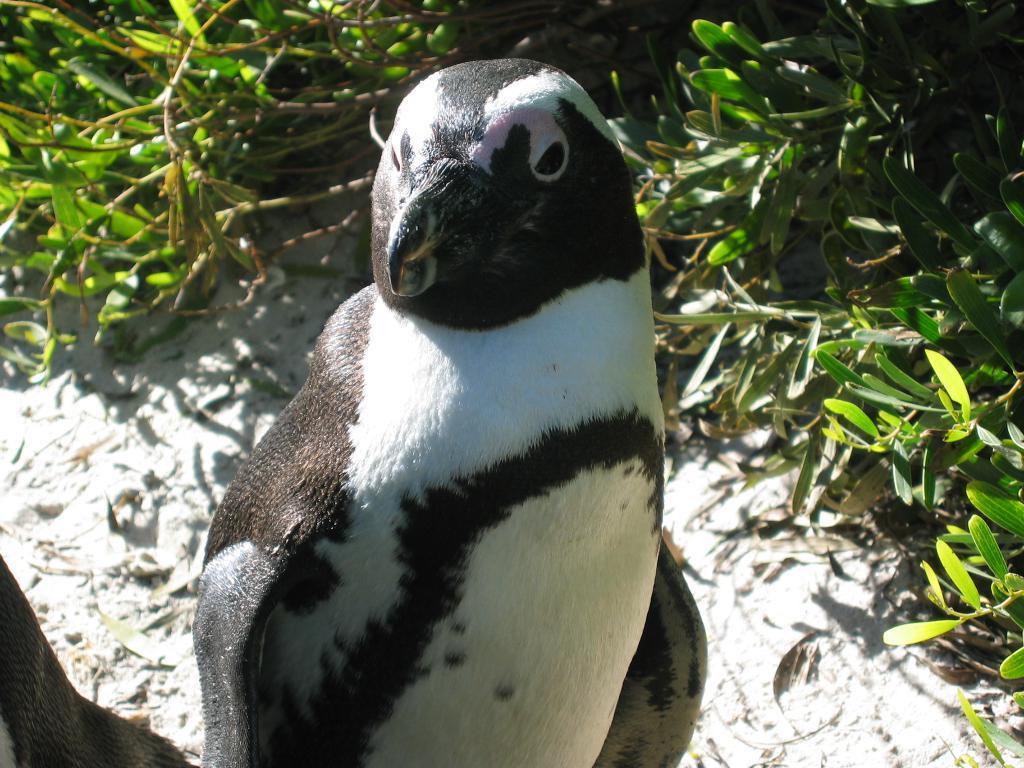Could you give a brief overview of what you see in this image? In this image we can see a penguin. In the background of the image there are plants. At the bottom of the image there is sand. 